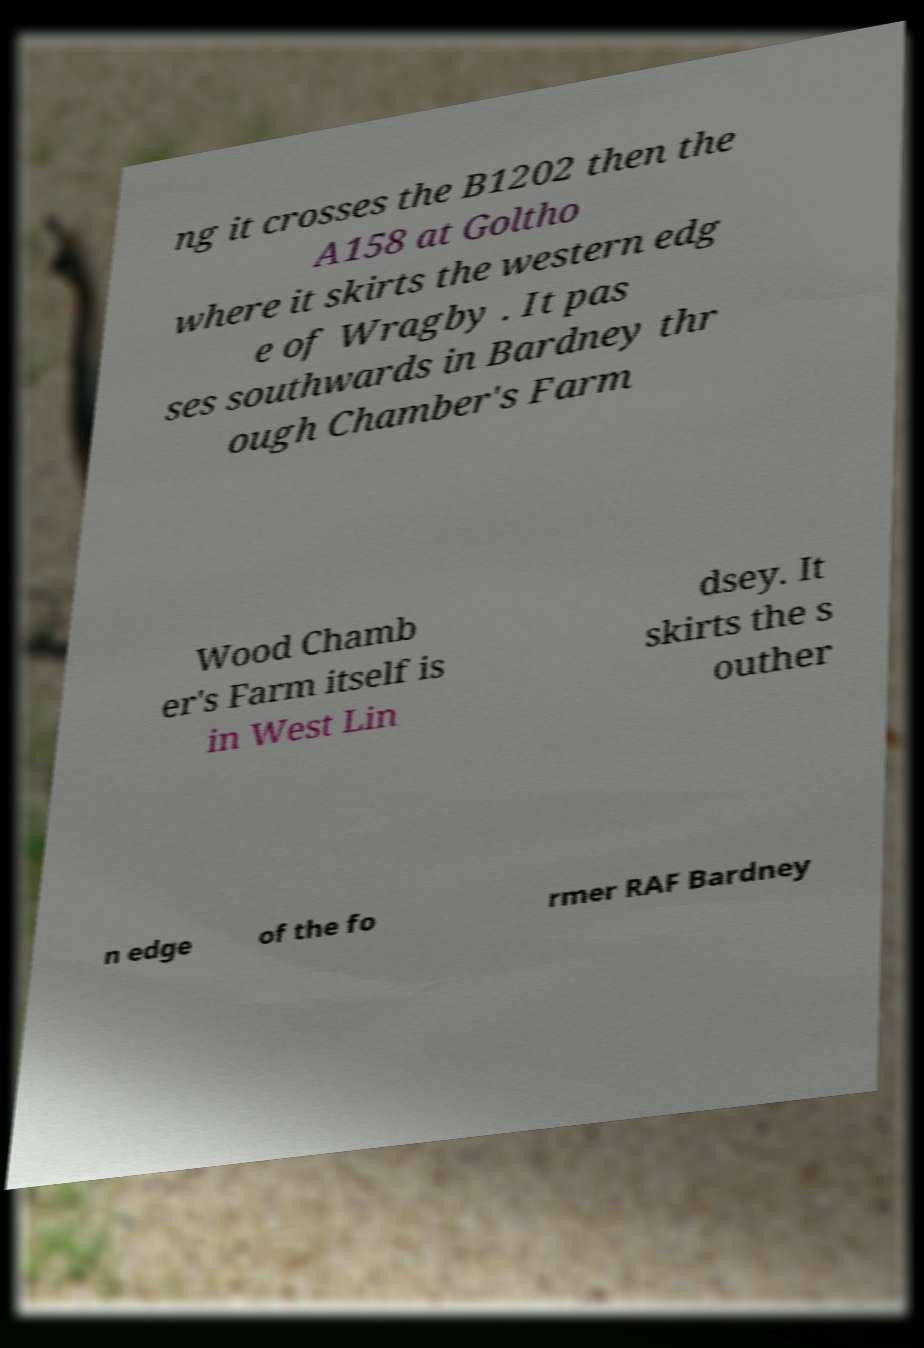Can you accurately transcribe the text from the provided image for me? ng it crosses the B1202 then the A158 at Goltho where it skirts the western edg e of Wragby . It pas ses southwards in Bardney thr ough Chamber's Farm Wood Chamb er's Farm itself is in West Lin dsey. It skirts the s outher n edge of the fo rmer RAF Bardney 